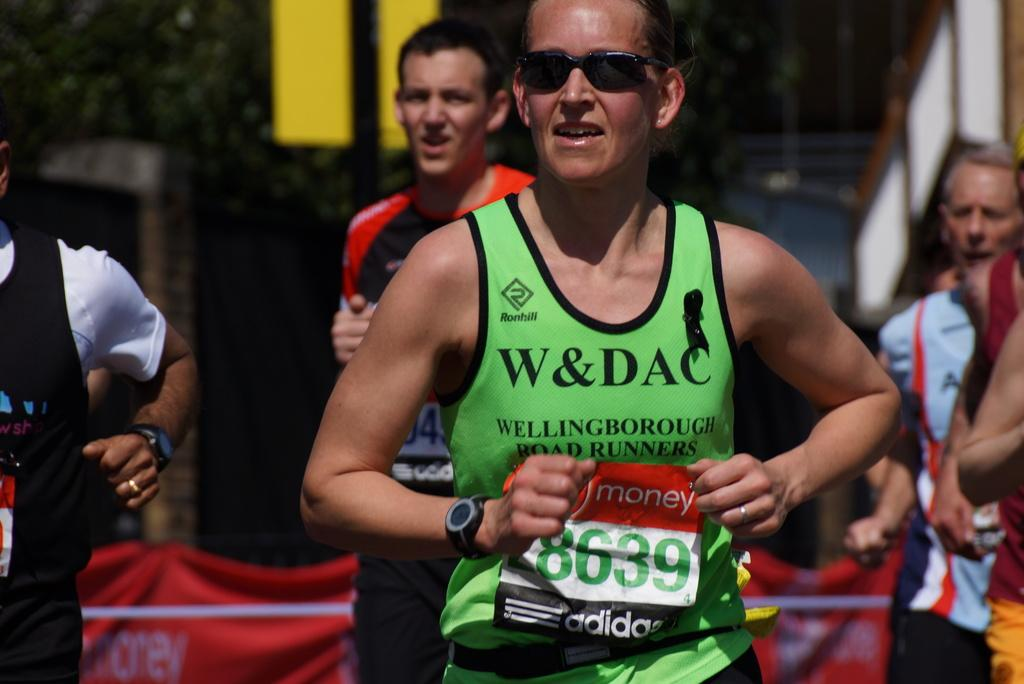<image>
Create a compact narrative representing the image presented. An athlete wearing bib number 8639 during a road race. 